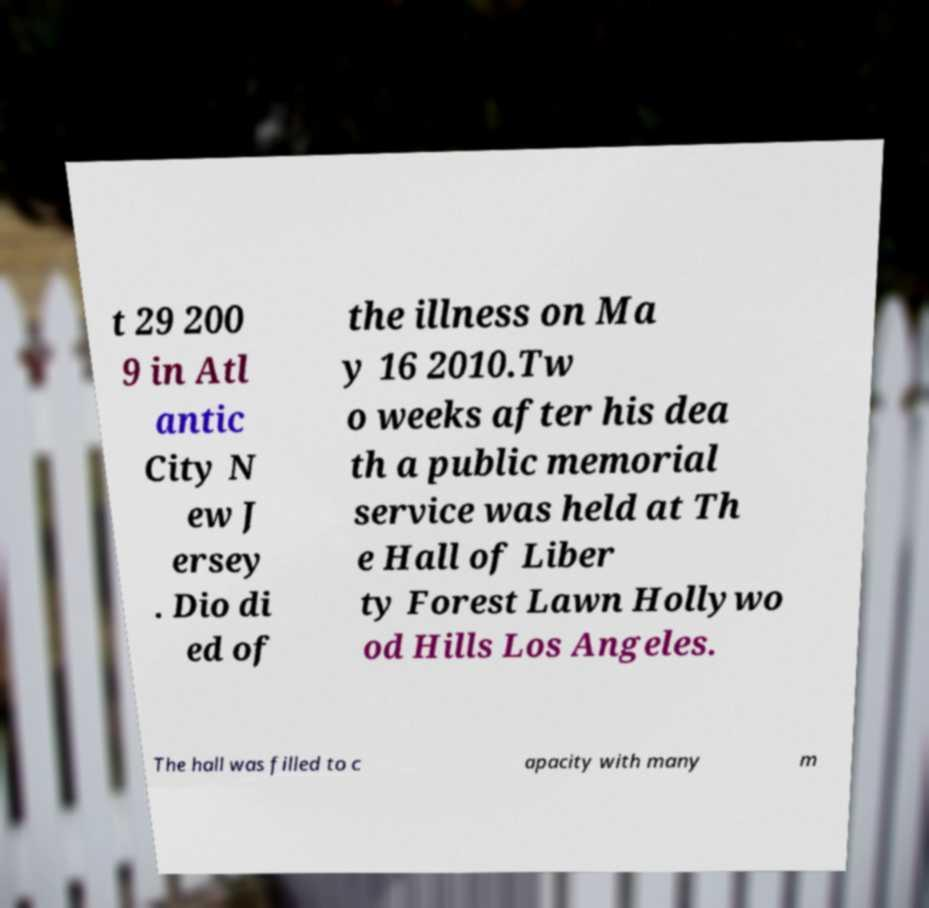Can you read and provide the text displayed in the image?This photo seems to have some interesting text. Can you extract and type it out for me? t 29 200 9 in Atl antic City N ew J ersey . Dio di ed of the illness on Ma y 16 2010.Tw o weeks after his dea th a public memorial service was held at Th e Hall of Liber ty Forest Lawn Hollywo od Hills Los Angeles. The hall was filled to c apacity with many m 